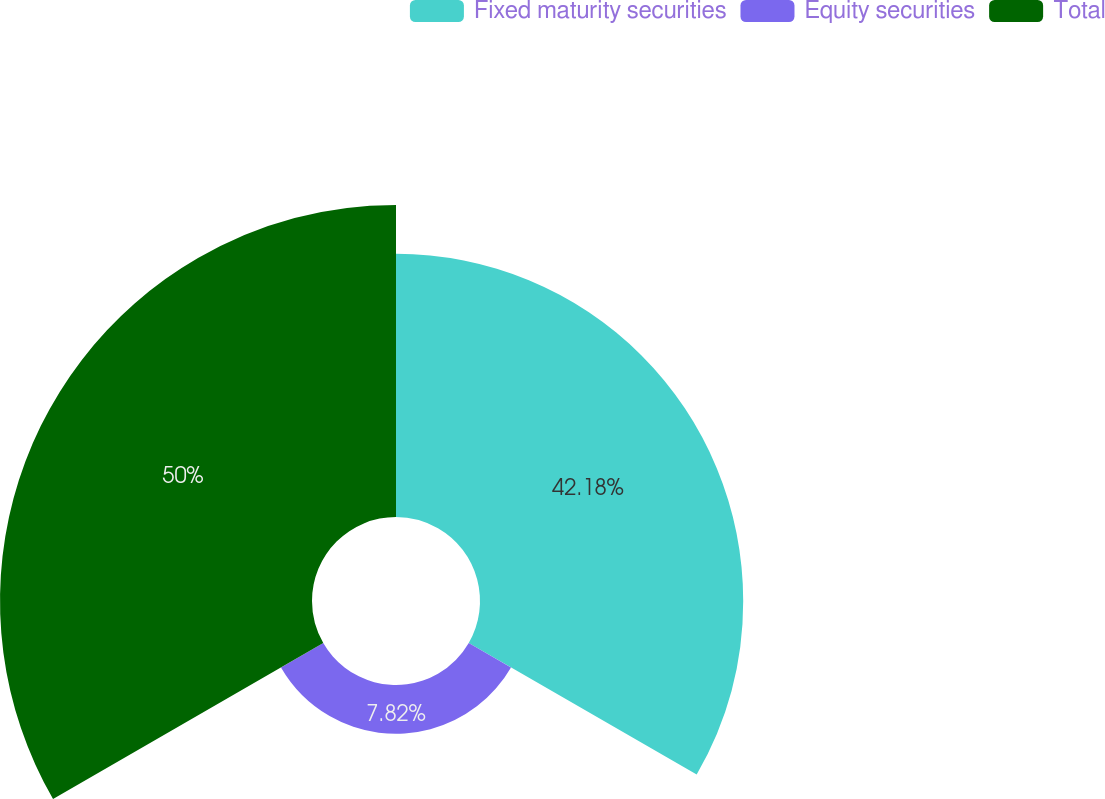<chart> <loc_0><loc_0><loc_500><loc_500><pie_chart><fcel>Fixed maturity securities<fcel>Equity securities<fcel>Total<nl><fcel>42.18%<fcel>7.82%<fcel>50.0%<nl></chart> 